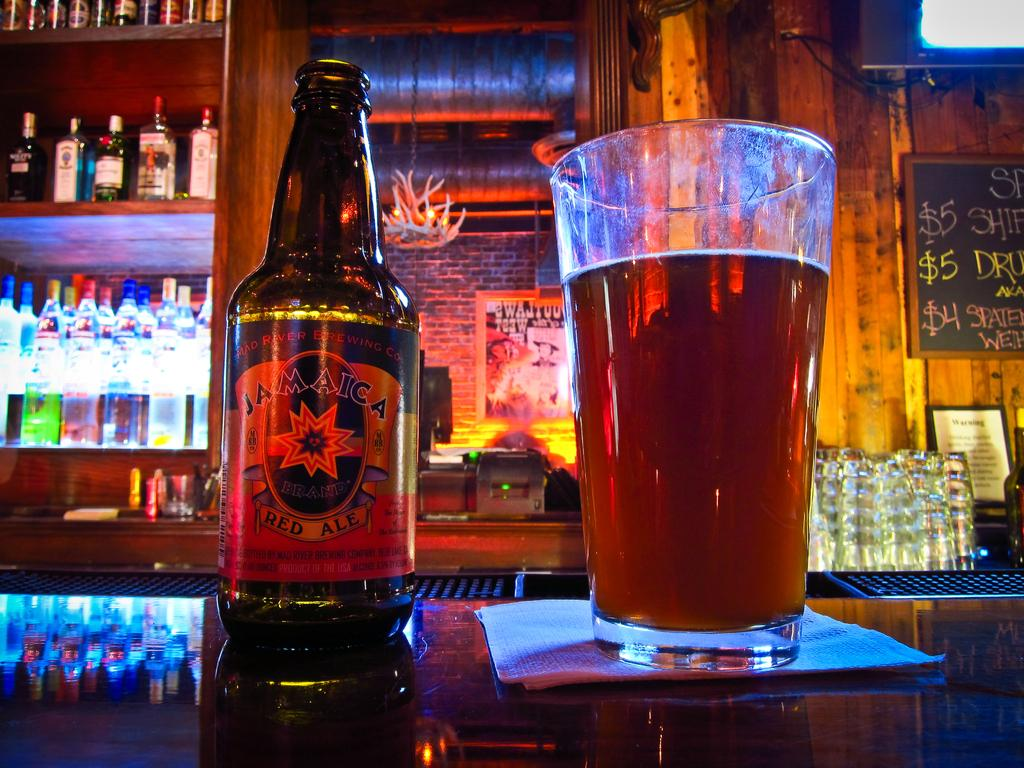What is the main object in the center of the image? There is a wine bottle and a glass in the center of the image. What is placed alongside the wine bottle and glass? There is tissue paper in the center of the image. Where are these objects located? The objects are on a table. What can be seen in the background of the image? There is a shelf with wine bottles, a table, a sign board, a light, and a brick wall in the background. Can you see a yak playing a guitar in the image? No, there is no yak or guitar present in the image. 